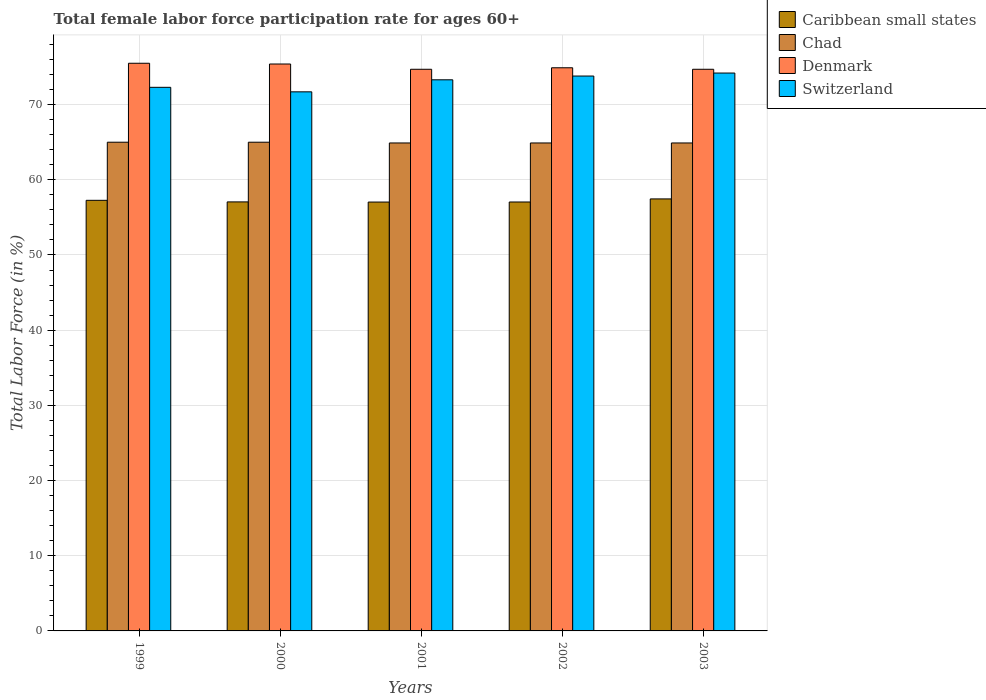How many different coloured bars are there?
Provide a succinct answer. 4. How many groups of bars are there?
Provide a short and direct response. 5. How many bars are there on the 5th tick from the right?
Offer a terse response. 4. In how many cases, is the number of bars for a given year not equal to the number of legend labels?
Give a very brief answer. 0. What is the female labor force participation rate in Chad in 2002?
Give a very brief answer. 64.9. Across all years, what is the maximum female labor force participation rate in Denmark?
Give a very brief answer. 75.5. Across all years, what is the minimum female labor force participation rate in Caribbean small states?
Make the answer very short. 57.04. What is the total female labor force participation rate in Switzerland in the graph?
Make the answer very short. 365.3. What is the difference between the female labor force participation rate in Caribbean small states in 2000 and that in 2002?
Make the answer very short. 0.01. What is the difference between the female labor force participation rate in Chad in 2000 and the female labor force participation rate in Caribbean small states in 2001?
Give a very brief answer. 7.96. What is the average female labor force participation rate in Chad per year?
Give a very brief answer. 64.94. In the year 2000, what is the difference between the female labor force participation rate in Caribbean small states and female labor force participation rate in Chad?
Provide a short and direct response. -7.94. What is the ratio of the female labor force participation rate in Switzerland in 2002 to that in 2003?
Offer a terse response. 0.99. Is the female labor force participation rate in Chad in 2000 less than that in 2003?
Provide a succinct answer. No. Is the difference between the female labor force participation rate in Caribbean small states in 2000 and 2003 greater than the difference between the female labor force participation rate in Chad in 2000 and 2003?
Provide a succinct answer. No. What is the difference between the highest and the second highest female labor force participation rate in Caribbean small states?
Provide a short and direct response. 0.19. What does the 2nd bar from the left in 1999 represents?
Make the answer very short. Chad. What does the 3rd bar from the right in 1999 represents?
Offer a very short reply. Chad. How many bars are there?
Your response must be concise. 20. How many years are there in the graph?
Give a very brief answer. 5. What is the difference between two consecutive major ticks on the Y-axis?
Provide a short and direct response. 10. Are the values on the major ticks of Y-axis written in scientific E-notation?
Offer a very short reply. No. Does the graph contain grids?
Make the answer very short. Yes. How are the legend labels stacked?
Your answer should be very brief. Vertical. What is the title of the graph?
Offer a terse response. Total female labor force participation rate for ages 60+. Does "Turkey" appear as one of the legend labels in the graph?
Your response must be concise. No. What is the label or title of the Y-axis?
Offer a very short reply. Total Labor Force (in %). What is the Total Labor Force (in %) in Caribbean small states in 1999?
Give a very brief answer. 57.27. What is the Total Labor Force (in %) of Chad in 1999?
Provide a succinct answer. 65. What is the Total Labor Force (in %) in Denmark in 1999?
Ensure brevity in your answer.  75.5. What is the Total Labor Force (in %) in Switzerland in 1999?
Give a very brief answer. 72.3. What is the Total Labor Force (in %) in Caribbean small states in 2000?
Provide a succinct answer. 57.06. What is the Total Labor Force (in %) in Chad in 2000?
Keep it short and to the point. 65. What is the Total Labor Force (in %) of Denmark in 2000?
Your answer should be very brief. 75.4. What is the Total Labor Force (in %) of Switzerland in 2000?
Give a very brief answer. 71.7. What is the Total Labor Force (in %) in Caribbean small states in 2001?
Provide a succinct answer. 57.04. What is the Total Labor Force (in %) in Chad in 2001?
Provide a succinct answer. 64.9. What is the Total Labor Force (in %) in Denmark in 2001?
Provide a short and direct response. 74.7. What is the Total Labor Force (in %) of Switzerland in 2001?
Provide a succinct answer. 73.3. What is the Total Labor Force (in %) in Caribbean small states in 2002?
Your answer should be very brief. 57.05. What is the Total Labor Force (in %) of Chad in 2002?
Your answer should be very brief. 64.9. What is the Total Labor Force (in %) in Denmark in 2002?
Your answer should be compact. 74.9. What is the Total Labor Force (in %) of Switzerland in 2002?
Ensure brevity in your answer.  73.8. What is the Total Labor Force (in %) in Caribbean small states in 2003?
Keep it short and to the point. 57.46. What is the Total Labor Force (in %) of Chad in 2003?
Provide a short and direct response. 64.9. What is the Total Labor Force (in %) of Denmark in 2003?
Your response must be concise. 74.7. What is the Total Labor Force (in %) of Switzerland in 2003?
Provide a short and direct response. 74.2. Across all years, what is the maximum Total Labor Force (in %) in Caribbean small states?
Your response must be concise. 57.46. Across all years, what is the maximum Total Labor Force (in %) of Denmark?
Give a very brief answer. 75.5. Across all years, what is the maximum Total Labor Force (in %) in Switzerland?
Give a very brief answer. 74.2. Across all years, what is the minimum Total Labor Force (in %) in Caribbean small states?
Keep it short and to the point. 57.04. Across all years, what is the minimum Total Labor Force (in %) in Chad?
Ensure brevity in your answer.  64.9. Across all years, what is the minimum Total Labor Force (in %) of Denmark?
Offer a terse response. 74.7. Across all years, what is the minimum Total Labor Force (in %) in Switzerland?
Make the answer very short. 71.7. What is the total Total Labor Force (in %) of Caribbean small states in the graph?
Your response must be concise. 285.88. What is the total Total Labor Force (in %) of Chad in the graph?
Offer a very short reply. 324.7. What is the total Total Labor Force (in %) of Denmark in the graph?
Make the answer very short. 375.2. What is the total Total Labor Force (in %) of Switzerland in the graph?
Offer a very short reply. 365.3. What is the difference between the Total Labor Force (in %) of Caribbean small states in 1999 and that in 2000?
Provide a succinct answer. 0.21. What is the difference between the Total Labor Force (in %) of Denmark in 1999 and that in 2000?
Provide a short and direct response. 0.1. What is the difference between the Total Labor Force (in %) of Caribbean small states in 1999 and that in 2001?
Your answer should be compact. 0.23. What is the difference between the Total Labor Force (in %) in Chad in 1999 and that in 2001?
Make the answer very short. 0.1. What is the difference between the Total Labor Force (in %) in Switzerland in 1999 and that in 2001?
Offer a very short reply. -1. What is the difference between the Total Labor Force (in %) of Caribbean small states in 1999 and that in 2002?
Keep it short and to the point. 0.22. What is the difference between the Total Labor Force (in %) of Switzerland in 1999 and that in 2002?
Provide a succinct answer. -1.5. What is the difference between the Total Labor Force (in %) in Caribbean small states in 1999 and that in 2003?
Make the answer very short. -0.19. What is the difference between the Total Labor Force (in %) of Chad in 1999 and that in 2003?
Keep it short and to the point. 0.1. What is the difference between the Total Labor Force (in %) in Caribbean small states in 2000 and that in 2001?
Ensure brevity in your answer.  0.02. What is the difference between the Total Labor Force (in %) in Chad in 2000 and that in 2001?
Offer a terse response. 0.1. What is the difference between the Total Labor Force (in %) in Switzerland in 2000 and that in 2001?
Provide a succinct answer. -1.6. What is the difference between the Total Labor Force (in %) of Caribbean small states in 2000 and that in 2002?
Your answer should be compact. 0.01. What is the difference between the Total Labor Force (in %) in Chad in 2000 and that in 2002?
Give a very brief answer. 0.1. What is the difference between the Total Labor Force (in %) in Denmark in 2000 and that in 2002?
Your answer should be very brief. 0.5. What is the difference between the Total Labor Force (in %) of Switzerland in 2000 and that in 2002?
Your answer should be very brief. -2.1. What is the difference between the Total Labor Force (in %) of Caribbean small states in 2000 and that in 2003?
Offer a terse response. -0.4. What is the difference between the Total Labor Force (in %) in Denmark in 2000 and that in 2003?
Ensure brevity in your answer.  0.7. What is the difference between the Total Labor Force (in %) of Switzerland in 2000 and that in 2003?
Provide a short and direct response. -2.5. What is the difference between the Total Labor Force (in %) in Caribbean small states in 2001 and that in 2002?
Offer a terse response. -0.01. What is the difference between the Total Labor Force (in %) in Caribbean small states in 2001 and that in 2003?
Ensure brevity in your answer.  -0.42. What is the difference between the Total Labor Force (in %) in Chad in 2001 and that in 2003?
Offer a very short reply. 0. What is the difference between the Total Labor Force (in %) in Denmark in 2001 and that in 2003?
Provide a short and direct response. 0. What is the difference between the Total Labor Force (in %) of Caribbean small states in 2002 and that in 2003?
Ensure brevity in your answer.  -0.41. What is the difference between the Total Labor Force (in %) in Switzerland in 2002 and that in 2003?
Keep it short and to the point. -0.4. What is the difference between the Total Labor Force (in %) in Caribbean small states in 1999 and the Total Labor Force (in %) in Chad in 2000?
Provide a short and direct response. -7.73. What is the difference between the Total Labor Force (in %) in Caribbean small states in 1999 and the Total Labor Force (in %) in Denmark in 2000?
Offer a terse response. -18.13. What is the difference between the Total Labor Force (in %) in Caribbean small states in 1999 and the Total Labor Force (in %) in Switzerland in 2000?
Provide a short and direct response. -14.43. What is the difference between the Total Labor Force (in %) of Chad in 1999 and the Total Labor Force (in %) of Denmark in 2000?
Give a very brief answer. -10.4. What is the difference between the Total Labor Force (in %) of Chad in 1999 and the Total Labor Force (in %) of Switzerland in 2000?
Your response must be concise. -6.7. What is the difference between the Total Labor Force (in %) in Denmark in 1999 and the Total Labor Force (in %) in Switzerland in 2000?
Make the answer very short. 3.8. What is the difference between the Total Labor Force (in %) in Caribbean small states in 1999 and the Total Labor Force (in %) in Chad in 2001?
Offer a terse response. -7.63. What is the difference between the Total Labor Force (in %) of Caribbean small states in 1999 and the Total Labor Force (in %) of Denmark in 2001?
Offer a very short reply. -17.43. What is the difference between the Total Labor Force (in %) in Caribbean small states in 1999 and the Total Labor Force (in %) in Switzerland in 2001?
Your response must be concise. -16.03. What is the difference between the Total Labor Force (in %) in Caribbean small states in 1999 and the Total Labor Force (in %) in Chad in 2002?
Give a very brief answer. -7.63. What is the difference between the Total Labor Force (in %) in Caribbean small states in 1999 and the Total Labor Force (in %) in Denmark in 2002?
Offer a very short reply. -17.63. What is the difference between the Total Labor Force (in %) in Caribbean small states in 1999 and the Total Labor Force (in %) in Switzerland in 2002?
Your answer should be very brief. -16.53. What is the difference between the Total Labor Force (in %) of Chad in 1999 and the Total Labor Force (in %) of Switzerland in 2002?
Give a very brief answer. -8.8. What is the difference between the Total Labor Force (in %) of Caribbean small states in 1999 and the Total Labor Force (in %) of Chad in 2003?
Offer a very short reply. -7.63. What is the difference between the Total Labor Force (in %) in Caribbean small states in 1999 and the Total Labor Force (in %) in Denmark in 2003?
Provide a short and direct response. -17.43. What is the difference between the Total Labor Force (in %) of Caribbean small states in 1999 and the Total Labor Force (in %) of Switzerland in 2003?
Your answer should be compact. -16.93. What is the difference between the Total Labor Force (in %) of Chad in 1999 and the Total Labor Force (in %) of Switzerland in 2003?
Offer a terse response. -9.2. What is the difference between the Total Labor Force (in %) of Denmark in 1999 and the Total Labor Force (in %) of Switzerland in 2003?
Provide a succinct answer. 1.3. What is the difference between the Total Labor Force (in %) in Caribbean small states in 2000 and the Total Labor Force (in %) in Chad in 2001?
Make the answer very short. -7.84. What is the difference between the Total Labor Force (in %) of Caribbean small states in 2000 and the Total Labor Force (in %) of Denmark in 2001?
Provide a short and direct response. -17.64. What is the difference between the Total Labor Force (in %) of Caribbean small states in 2000 and the Total Labor Force (in %) of Switzerland in 2001?
Ensure brevity in your answer.  -16.24. What is the difference between the Total Labor Force (in %) of Chad in 2000 and the Total Labor Force (in %) of Switzerland in 2001?
Give a very brief answer. -8.3. What is the difference between the Total Labor Force (in %) in Caribbean small states in 2000 and the Total Labor Force (in %) in Chad in 2002?
Your answer should be very brief. -7.84. What is the difference between the Total Labor Force (in %) in Caribbean small states in 2000 and the Total Labor Force (in %) in Denmark in 2002?
Your response must be concise. -17.84. What is the difference between the Total Labor Force (in %) in Caribbean small states in 2000 and the Total Labor Force (in %) in Switzerland in 2002?
Provide a succinct answer. -16.74. What is the difference between the Total Labor Force (in %) of Caribbean small states in 2000 and the Total Labor Force (in %) of Chad in 2003?
Provide a short and direct response. -7.84. What is the difference between the Total Labor Force (in %) in Caribbean small states in 2000 and the Total Labor Force (in %) in Denmark in 2003?
Provide a short and direct response. -17.64. What is the difference between the Total Labor Force (in %) in Caribbean small states in 2000 and the Total Labor Force (in %) in Switzerland in 2003?
Make the answer very short. -17.14. What is the difference between the Total Labor Force (in %) in Chad in 2000 and the Total Labor Force (in %) in Switzerland in 2003?
Give a very brief answer. -9.2. What is the difference between the Total Labor Force (in %) in Denmark in 2000 and the Total Labor Force (in %) in Switzerland in 2003?
Provide a short and direct response. 1.2. What is the difference between the Total Labor Force (in %) in Caribbean small states in 2001 and the Total Labor Force (in %) in Chad in 2002?
Make the answer very short. -7.86. What is the difference between the Total Labor Force (in %) of Caribbean small states in 2001 and the Total Labor Force (in %) of Denmark in 2002?
Ensure brevity in your answer.  -17.86. What is the difference between the Total Labor Force (in %) in Caribbean small states in 2001 and the Total Labor Force (in %) in Switzerland in 2002?
Offer a terse response. -16.76. What is the difference between the Total Labor Force (in %) in Chad in 2001 and the Total Labor Force (in %) in Denmark in 2002?
Provide a short and direct response. -10. What is the difference between the Total Labor Force (in %) of Chad in 2001 and the Total Labor Force (in %) of Switzerland in 2002?
Provide a short and direct response. -8.9. What is the difference between the Total Labor Force (in %) of Denmark in 2001 and the Total Labor Force (in %) of Switzerland in 2002?
Provide a short and direct response. 0.9. What is the difference between the Total Labor Force (in %) of Caribbean small states in 2001 and the Total Labor Force (in %) of Chad in 2003?
Offer a very short reply. -7.86. What is the difference between the Total Labor Force (in %) of Caribbean small states in 2001 and the Total Labor Force (in %) of Denmark in 2003?
Give a very brief answer. -17.66. What is the difference between the Total Labor Force (in %) in Caribbean small states in 2001 and the Total Labor Force (in %) in Switzerland in 2003?
Keep it short and to the point. -17.16. What is the difference between the Total Labor Force (in %) in Chad in 2001 and the Total Labor Force (in %) in Switzerland in 2003?
Provide a short and direct response. -9.3. What is the difference between the Total Labor Force (in %) in Denmark in 2001 and the Total Labor Force (in %) in Switzerland in 2003?
Offer a very short reply. 0.5. What is the difference between the Total Labor Force (in %) in Caribbean small states in 2002 and the Total Labor Force (in %) in Chad in 2003?
Offer a very short reply. -7.85. What is the difference between the Total Labor Force (in %) of Caribbean small states in 2002 and the Total Labor Force (in %) of Denmark in 2003?
Offer a very short reply. -17.65. What is the difference between the Total Labor Force (in %) in Caribbean small states in 2002 and the Total Labor Force (in %) in Switzerland in 2003?
Offer a very short reply. -17.15. What is the difference between the Total Labor Force (in %) of Chad in 2002 and the Total Labor Force (in %) of Switzerland in 2003?
Make the answer very short. -9.3. What is the difference between the Total Labor Force (in %) in Denmark in 2002 and the Total Labor Force (in %) in Switzerland in 2003?
Offer a terse response. 0.7. What is the average Total Labor Force (in %) in Caribbean small states per year?
Your response must be concise. 57.18. What is the average Total Labor Force (in %) of Chad per year?
Make the answer very short. 64.94. What is the average Total Labor Force (in %) of Denmark per year?
Keep it short and to the point. 75.04. What is the average Total Labor Force (in %) in Switzerland per year?
Offer a very short reply. 73.06. In the year 1999, what is the difference between the Total Labor Force (in %) of Caribbean small states and Total Labor Force (in %) of Chad?
Keep it short and to the point. -7.73. In the year 1999, what is the difference between the Total Labor Force (in %) of Caribbean small states and Total Labor Force (in %) of Denmark?
Keep it short and to the point. -18.23. In the year 1999, what is the difference between the Total Labor Force (in %) in Caribbean small states and Total Labor Force (in %) in Switzerland?
Ensure brevity in your answer.  -15.03. In the year 1999, what is the difference between the Total Labor Force (in %) of Denmark and Total Labor Force (in %) of Switzerland?
Offer a terse response. 3.2. In the year 2000, what is the difference between the Total Labor Force (in %) of Caribbean small states and Total Labor Force (in %) of Chad?
Give a very brief answer. -7.94. In the year 2000, what is the difference between the Total Labor Force (in %) of Caribbean small states and Total Labor Force (in %) of Denmark?
Keep it short and to the point. -18.34. In the year 2000, what is the difference between the Total Labor Force (in %) in Caribbean small states and Total Labor Force (in %) in Switzerland?
Provide a short and direct response. -14.64. In the year 2000, what is the difference between the Total Labor Force (in %) of Chad and Total Labor Force (in %) of Denmark?
Your answer should be very brief. -10.4. In the year 2001, what is the difference between the Total Labor Force (in %) in Caribbean small states and Total Labor Force (in %) in Chad?
Ensure brevity in your answer.  -7.86. In the year 2001, what is the difference between the Total Labor Force (in %) in Caribbean small states and Total Labor Force (in %) in Denmark?
Ensure brevity in your answer.  -17.66. In the year 2001, what is the difference between the Total Labor Force (in %) of Caribbean small states and Total Labor Force (in %) of Switzerland?
Your answer should be very brief. -16.26. In the year 2002, what is the difference between the Total Labor Force (in %) in Caribbean small states and Total Labor Force (in %) in Chad?
Offer a terse response. -7.85. In the year 2002, what is the difference between the Total Labor Force (in %) in Caribbean small states and Total Labor Force (in %) in Denmark?
Ensure brevity in your answer.  -17.85. In the year 2002, what is the difference between the Total Labor Force (in %) of Caribbean small states and Total Labor Force (in %) of Switzerland?
Keep it short and to the point. -16.75. In the year 2002, what is the difference between the Total Labor Force (in %) of Chad and Total Labor Force (in %) of Denmark?
Keep it short and to the point. -10. In the year 2002, what is the difference between the Total Labor Force (in %) in Denmark and Total Labor Force (in %) in Switzerland?
Give a very brief answer. 1.1. In the year 2003, what is the difference between the Total Labor Force (in %) of Caribbean small states and Total Labor Force (in %) of Chad?
Give a very brief answer. -7.44. In the year 2003, what is the difference between the Total Labor Force (in %) of Caribbean small states and Total Labor Force (in %) of Denmark?
Your answer should be compact. -17.24. In the year 2003, what is the difference between the Total Labor Force (in %) of Caribbean small states and Total Labor Force (in %) of Switzerland?
Your answer should be compact. -16.74. In the year 2003, what is the difference between the Total Labor Force (in %) in Denmark and Total Labor Force (in %) in Switzerland?
Your answer should be compact. 0.5. What is the ratio of the Total Labor Force (in %) of Chad in 1999 to that in 2000?
Offer a terse response. 1. What is the ratio of the Total Labor Force (in %) of Denmark in 1999 to that in 2000?
Give a very brief answer. 1. What is the ratio of the Total Labor Force (in %) of Switzerland in 1999 to that in 2000?
Your answer should be compact. 1.01. What is the ratio of the Total Labor Force (in %) of Caribbean small states in 1999 to that in 2001?
Provide a short and direct response. 1. What is the ratio of the Total Labor Force (in %) in Denmark in 1999 to that in 2001?
Your response must be concise. 1.01. What is the ratio of the Total Labor Force (in %) in Switzerland in 1999 to that in 2001?
Offer a terse response. 0.99. What is the ratio of the Total Labor Force (in %) in Caribbean small states in 1999 to that in 2002?
Offer a very short reply. 1. What is the ratio of the Total Labor Force (in %) of Denmark in 1999 to that in 2002?
Your answer should be compact. 1.01. What is the ratio of the Total Labor Force (in %) in Switzerland in 1999 to that in 2002?
Provide a succinct answer. 0.98. What is the ratio of the Total Labor Force (in %) of Caribbean small states in 1999 to that in 2003?
Offer a terse response. 1. What is the ratio of the Total Labor Force (in %) of Denmark in 1999 to that in 2003?
Provide a short and direct response. 1.01. What is the ratio of the Total Labor Force (in %) of Switzerland in 1999 to that in 2003?
Provide a short and direct response. 0.97. What is the ratio of the Total Labor Force (in %) in Caribbean small states in 2000 to that in 2001?
Keep it short and to the point. 1. What is the ratio of the Total Labor Force (in %) in Chad in 2000 to that in 2001?
Offer a terse response. 1. What is the ratio of the Total Labor Force (in %) in Denmark in 2000 to that in 2001?
Ensure brevity in your answer.  1.01. What is the ratio of the Total Labor Force (in %) of Switzerland in 2000 to that in 2001?
Give a very brief answer. 0.98. What is the ratio of the Total Labor Force (in %) of Denmark in 2000 to that in 2002?
Your answer should be compact. 1.01. What is the ratio of the Total Labor Force (in %) of Switzerland in 2000 to that in 2002?
Keep it short and to the point. 0.97. What is the ratio of the Total Labor Force (in %) of Denmark in 2000 to that in 2003?
Ensure brevity in your answer.  1.01. What is the ratio of the Total Labor Force (in %) in Switzerland in 2000 to that in 2003?
Provide a succinct answer. 0.97. What is the ratio of the Total Labor Force (in %) of Caribbean small states in 2001 to that in 2003?
Offer a terse response. 0.99. What is the ratio of the Total Labor Force (in %) of Chad in 2001 to that in 2003?
Your answer should be compact. 1. What is the ratio of the Total Labor Force (in %) of Denmark in 2001 to that in 2003?
Offer a terse response. 1. What is the ratio of the Total Labor Force (in %) of Switzerland in 2001 to that in 2003?
Give a very brief answer. 0.99. What is the difference between the highest and the second highest Total Labor Force (in %) of Caribbean small states?
Provide a short and direct response. 0.19. What is the difference between the highest and the second highest Total Labor Force (in %) of Denmark?
Provide a short and direct response. 0.1. What is the difference between the highest and the second highest Total Labor Force (in %) of Switzerland?
Give a very brief answer. 0.4. What is the difference between the highest and the lowest Total Labor Force (in %) in Caribbean small states?
Offer a terse response. 0.42. 